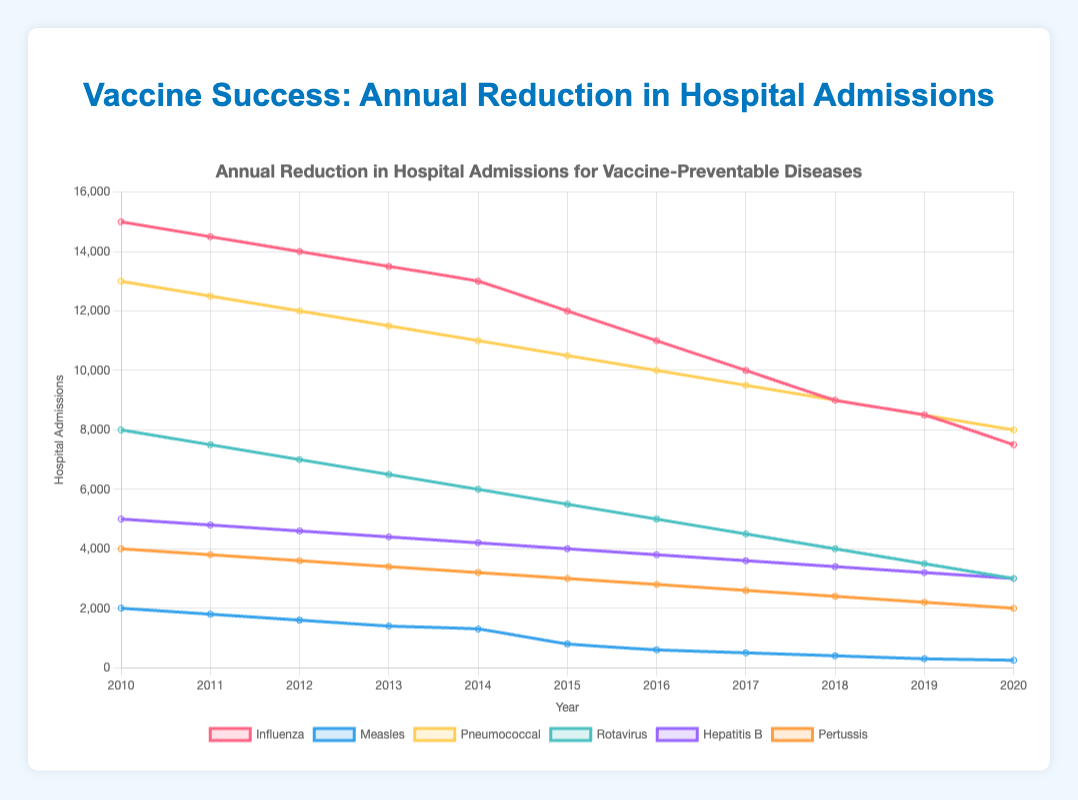Which disease had the highest reduction in hospital admissions in 2020? To find the disease with the highest reduction, look for the lowest hospital admission number in 2020. The data shows that measles had the lowest admissions at 250.
Answer: Measles How did the hospital admissions for rotavirus change between 2010 and 2020? To determine the change in rotavirus hospital admissions, subtract the 2020 value from the 2010 value: 8000 - 3000 = 5000.
Answer: 5000 Compare the reduction rates of influenza and pertussis from 2015 to 2020. Which one saw a larger drop? Calculate the difference for both diseases between 2015 and 2020. Influenza: 12000 - 7500 = 4500. Pertussis: 3000 - 2000 = 1000. Influenza saw a larger drop.
Answer: Influenza In which year did hepatitis B hospital admissions first fall below 4500? Check the data for hepatitis B year-wise until it first falls below 4500. In 2015, the value is 4000, the first time it falls below 4500.
Answer: 2015 What is the overall trend for pneumococcal hospital admissions from 2010 to 2020? Observe the pneumococcal line from 2010 to 2020. The admissions consistently decrease from 13000 to 8000, indicating a downward trend.
Answer: Downward trend Between 2014 and 2016, which disease showed the greatest reduction in hospital admissions? Calculate the difference for each disease between 2014 and 2016. Influenza: 13000 - 11000 = 2000, Measles: 1300 - 600 = 700, Pneumococcal: 11000 - 10000 = 1000, Rotavirus: 6000 - 5000 = 1000, Hepatitis B: 4200 - 3800 = 400, Pertussis: 3200 - 2800 = 400. Influenza had the greatest reduction (2000).
Answer: Influenza What is the average reduction in hospital admissions for measles from 2010 to 2020? Compute the reduction for each year and find the average. (2000 - 1800) + (1800 - 1600) + ... + (300 - 250) = 1750, average = 1750 / 10 = 175.
Answer: 175 What was the percentage reduction in hospital admissions for rotavirus from 2010 to 2020? Calculate the reduction amount and then the percentage. Initial value = 8000, final value = 3000, reduction = 8000 - 3000 = 5000. Percentage reduction = (5000 / 8000) * 100 = 62.5%.
Answer: 62.5% Which disease had the second-lowest hospital admissions in 2019? Identify the admissions for each disease in 2019. Measles = 300, Hepatitis B = 3200, Influenza = 8500, Pneumococcal = 8500, Rotavirus = 3500, Pertussis = 2200. The second lowest is Pertussis with 2200.
Answer: Pertussis 